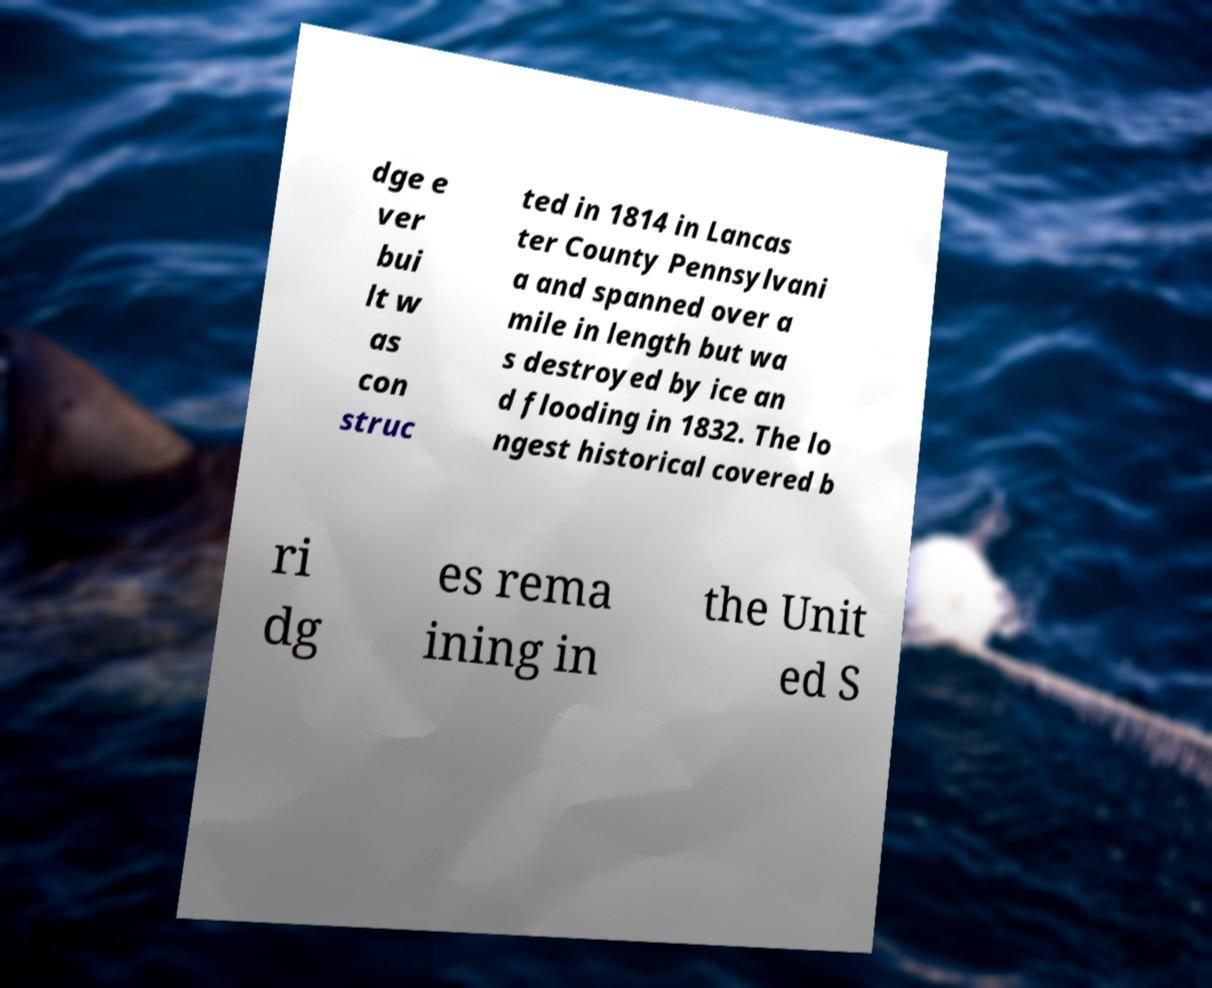Could you assist in decoding the text presented in this image and type it out clearly? dge e ver bui lt w as con struc ted in 1814 in Lancas ter County Pennsylvani a and spanned over a mile in length but wa s destroyed by ice an d flooding in 1832. The lo ngest historical covered b ri dg es rema ining in the Unit ed S 